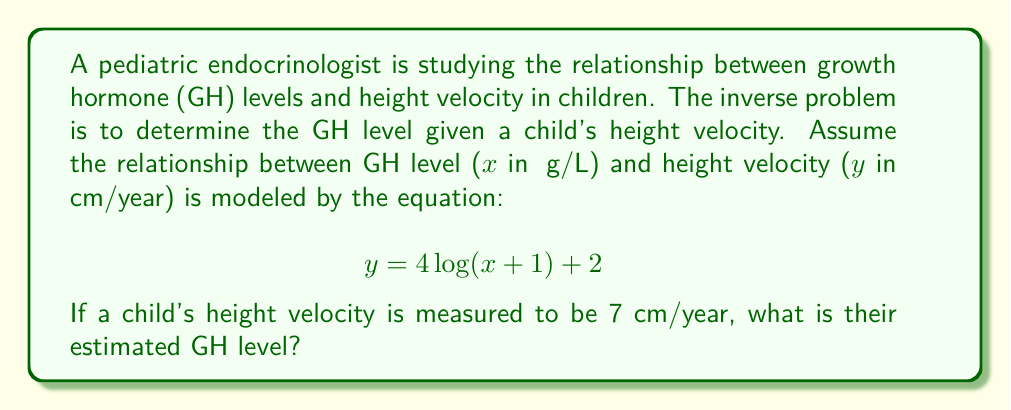Can you solve this math problem? To solve this inverse problem, we need to work backwards from the given height velocity to determine the GH level:

1) We start with the equation:
   $$ y = 4\log(x+1) + 2 $$

2) Substitute the known height velocity:
   $$ 7 = 4\log(x+1) + 2 $$

3) Subtract 2 from both sides:
   $$ 5 = 4\log(x+1) $$

4) Divide both sides by 4:
   $$ \frac{5}{4} = \log(x+1) $$

5) Apply the exponential function to both sides to isolate $x+1$:
   $$ e^{\frac{5}{4}} = x+1 $$

6) Subtract 1 from both sides to isolate $x$:
   $$ e^{\frac{5}{4}} - 1 = x $$

7) Calculate the final value:
   $$ x = e^{1.25} - 1 \approx 2.49 $$

Therefore, the estimated GH level is approximately 2.49 μg/L.
Answer: 2.49 μg/L 